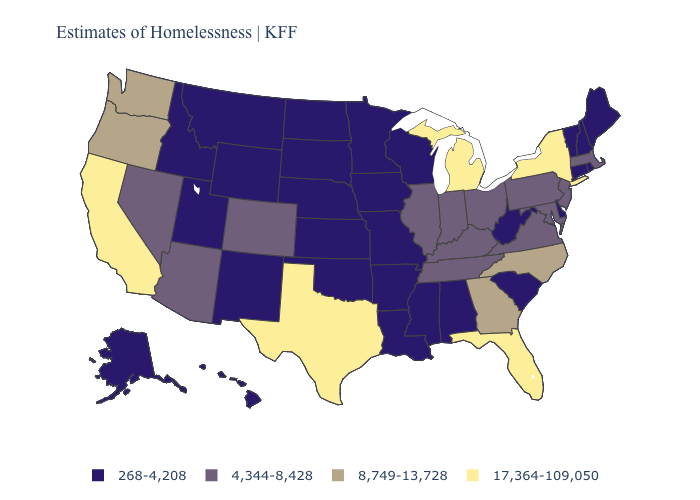What is the highest value in the MidWest ?
Keep it brief. 17,364-109,050. Does New York have the same value as California?
Keep it brief. Yes. Does Washington have the lowest value in the West?
Answer briefly. No. What is the value of Oregon?
Answer briefly. 8,749-13,728. Does New Hampshire have the highest value in the USA?
Quick response, please. No. Which states have the highest value in the USA?
Be succinct. California, Florida, Michigan, New York, Texas. Among the states that border Kansas , which have the lowest value?
Write a very short answer. Missouri, Nebraska, Oklahoma. Which states have the lowest value in the West?
Write a very short answer. Alaska, Hawaii, Idaho, Montana, New Mexico, Utah, Wyoming. What is the highest value in the USA?
Answer briefly. 17,364-109,050. Does the first symbol in the legend represent the smallest category?
Short answer required. Yes. What is the lowest value in states that border Montana?
Give a very brief answer. 268-4,208. What is the lowest value in states that border Iowa?
Short answer required. 268-4,208. What is the lowest value in states that border Missouri?
Write a very short answer. 268-4,208. Does the map have missing data?
Write a very short answer. No. Name the states that have a value in the range 17,364-109,050?
Be succinct. California, Florida, Michigan, New York, Texas. 